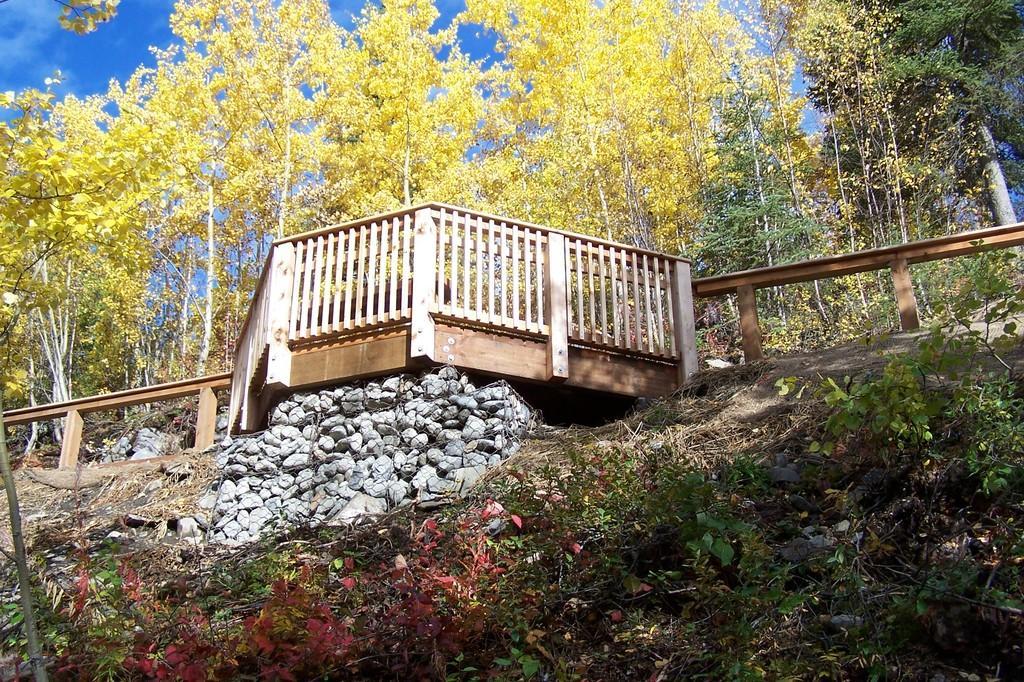Could you give a brief overview of what you see in this image? In this image I can see few stones, few plants, few flowers which are pink in color and the wooden railing. In the background I can see few trees which are green and yellow in color and the sky which is blue in color. 